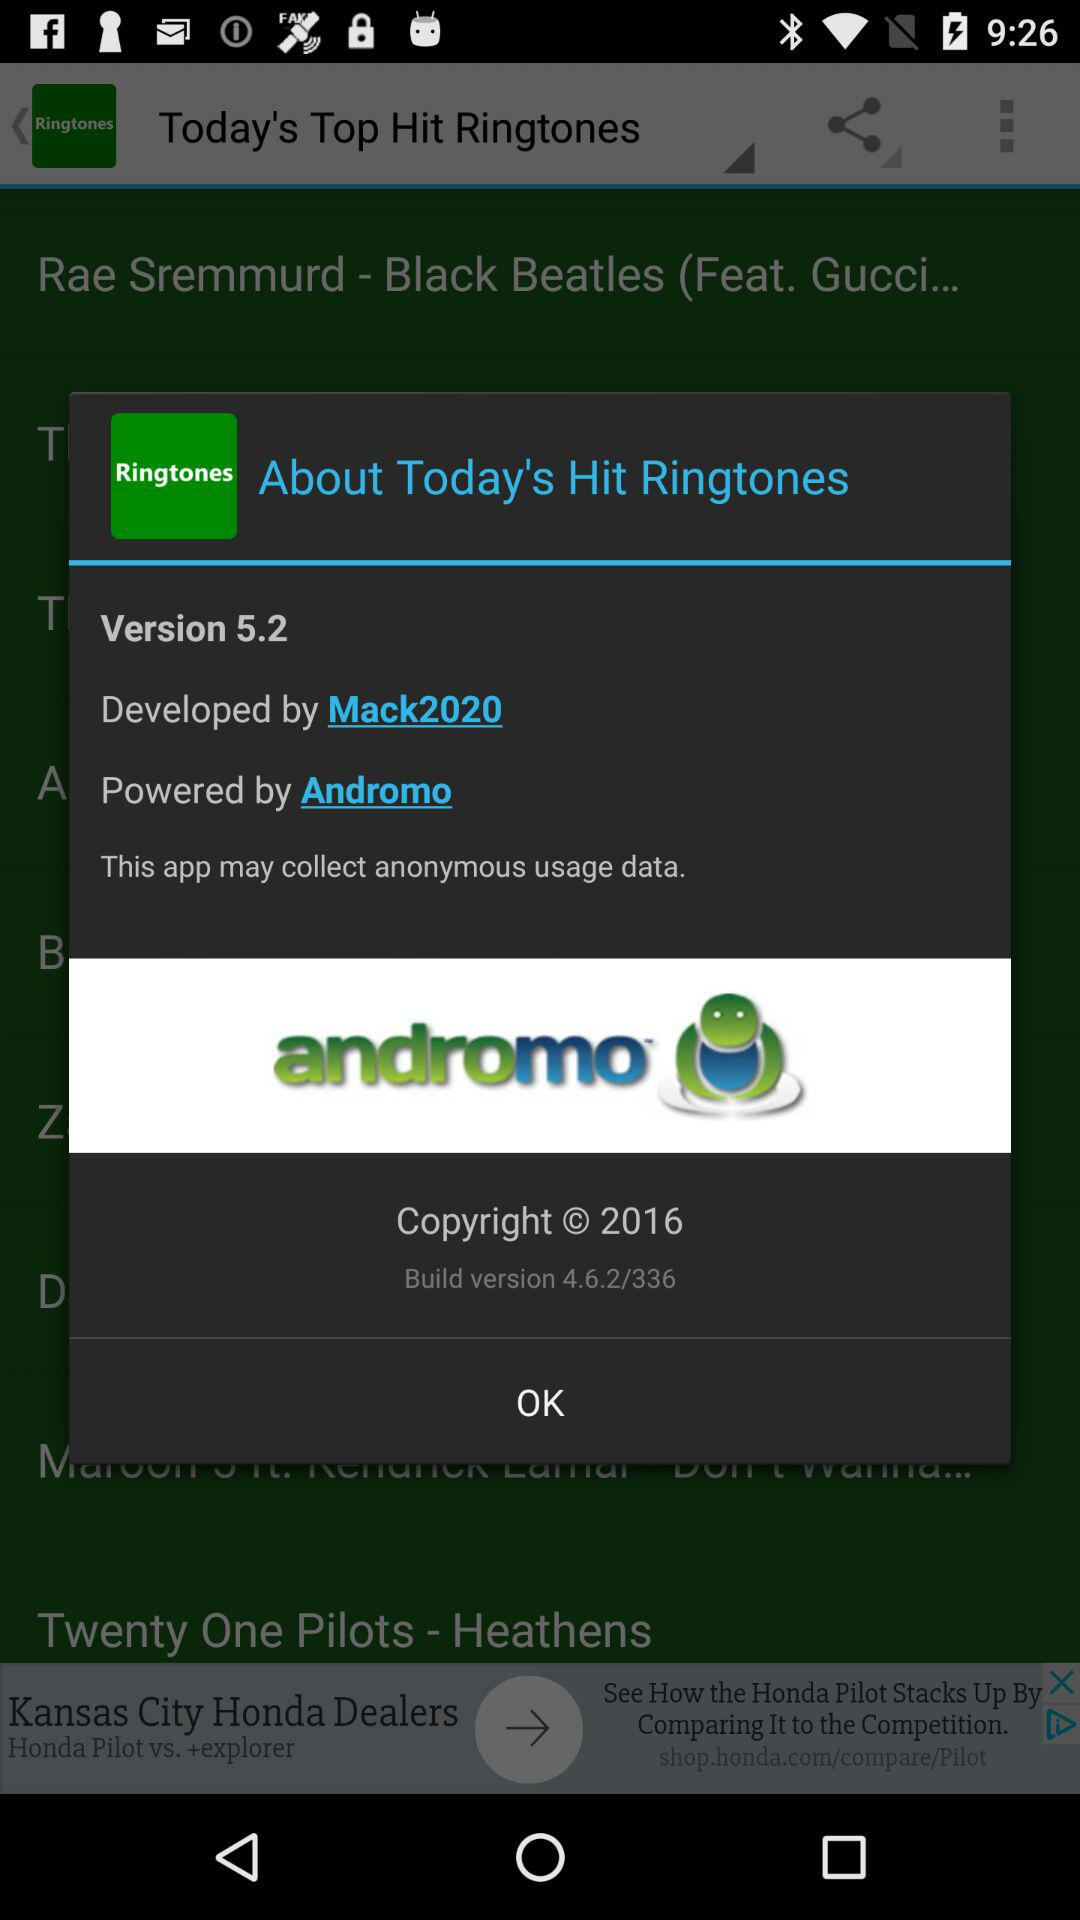What's the current version? The current version is 5.2. 